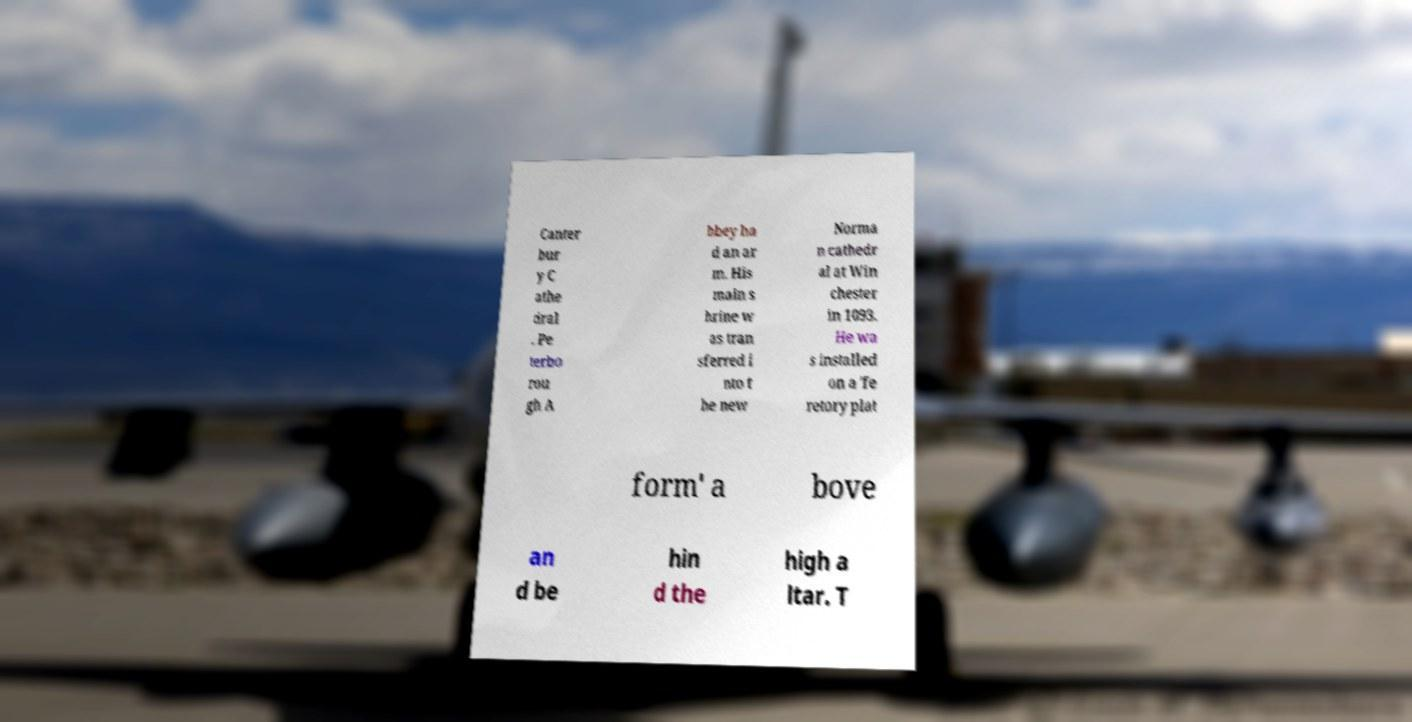For documentation purposes, I need the text within this image transcribed. Could you provide that? Canter bur y C athe dral . Pe terbo rou gh A bbey ha d an ar m. His main s hrine w as tran sferred i nto t he new Norma n cathedr al at Win chester in 1093. He wa s installed on a 'fe retory plat form' a bove an d be hin d the high a ltar. T 